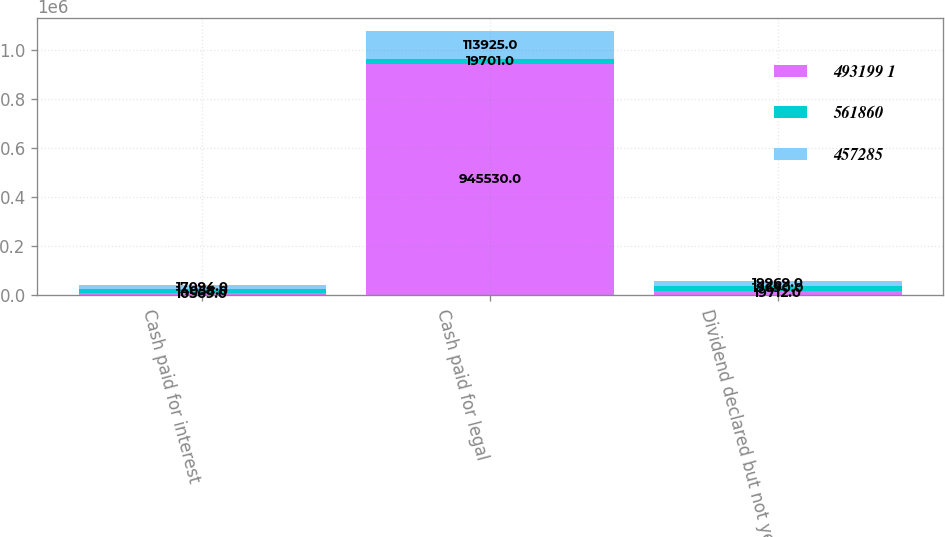<chart> <loc_0><loc_0><loc_500><loc_500><stacked_bar_chart><ecel><fcel>Cash paid for interest<fcel>Cash paid for legal<fcel>Dividend declared but not yet<nl><fcel>493199 1<fcel>10569<fcel>945530<fcel>19712<nl><fcel>561860<fcel>14058<fcel>19701<fcel>19690<nl><fcel>457285<fcel>17094<fcel>113925<fcel>19969<nl></chart> 